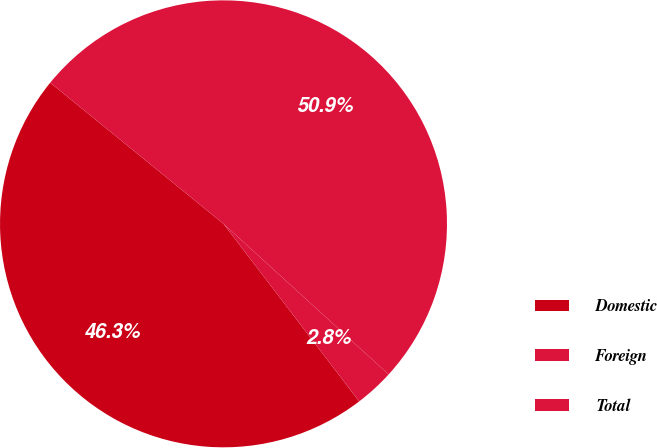Convert chart to OTSL. <chart><loc_0><loc_0><loc_500><loc_500><pie_chart><fcel>Domestic<fcel>Foreign<fcel>Total<nl><fcel>46.26%<fcel>2.85%<fcel>50.89%<nl></chart> 